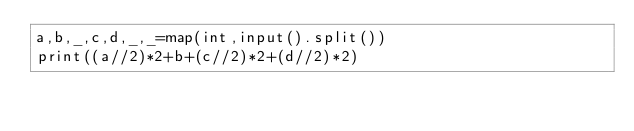<code> <loc_0><loc_0><loc_500><loc_500><_Python_>a,b,_,c,d,_,_=map(int,input().split())
print((a//2)*2+b+(c//2)*2+(d//2)*2)</code> 